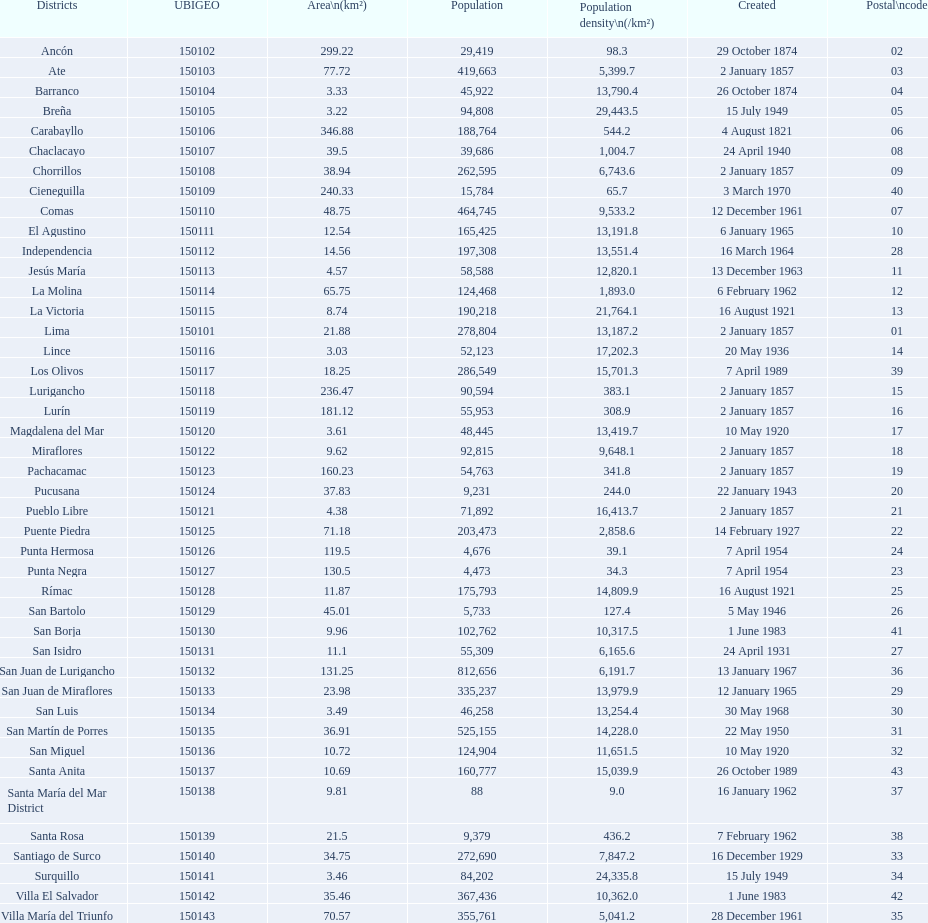How many districts are there in this city? 43. 